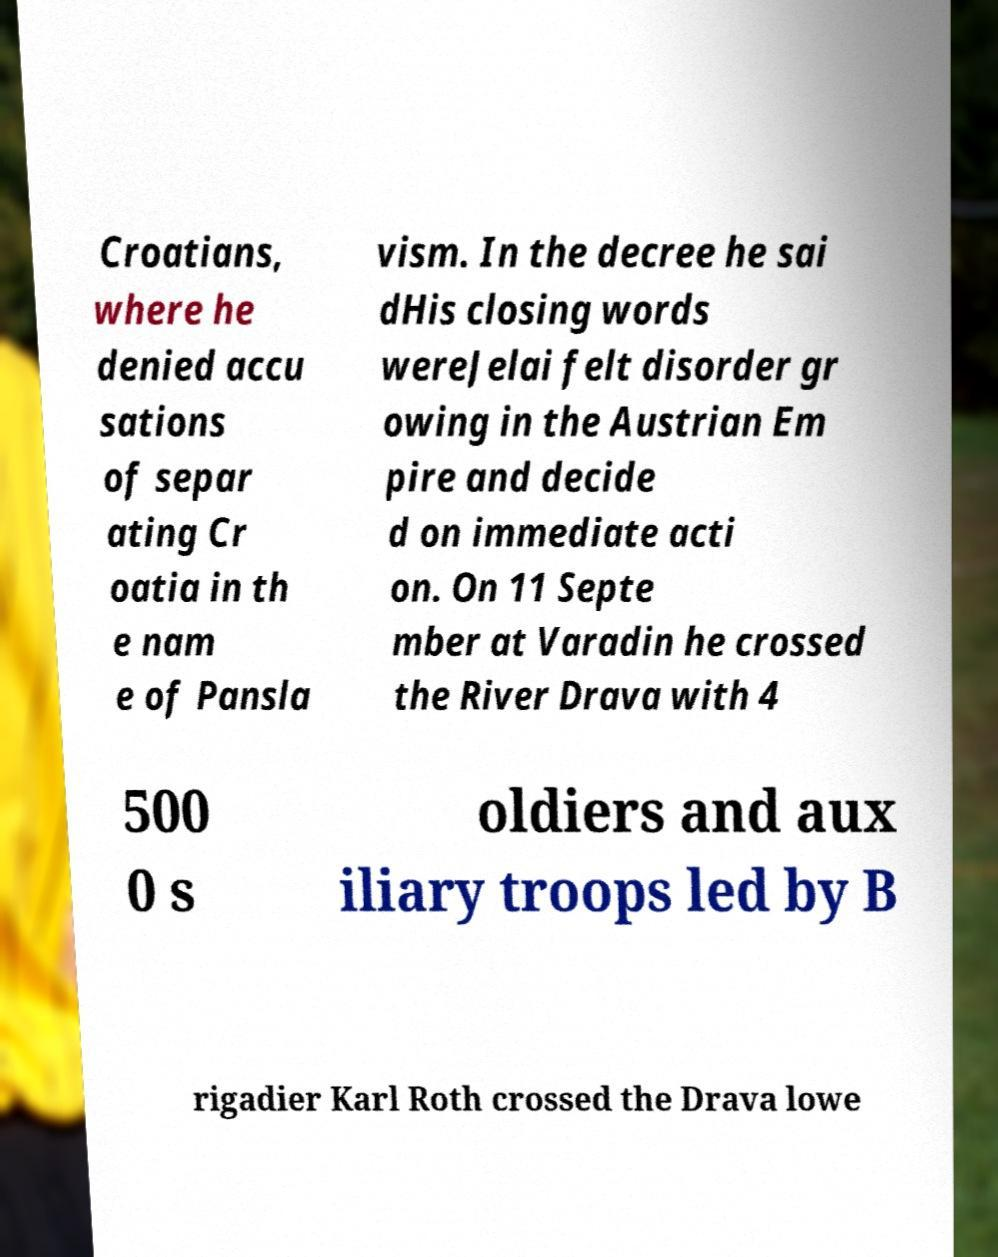There's text embedded in this image that I need extracted. Can you transcribe it verbatim? Croatians, where he denied accu sations of separ ating Cr oatia in th e nam e of Pansla vism. In the decree he sai dHis closing words wereJelai felt disorder gr owing in the Austrian Em pire and decide d on immediate acti on. On 11 Septe mber at Varadin he crossed the River Drava with 4 500 0 s oldiers and aux iliary troops led by B rigadier Karl Roth crossed the Drava lowe 